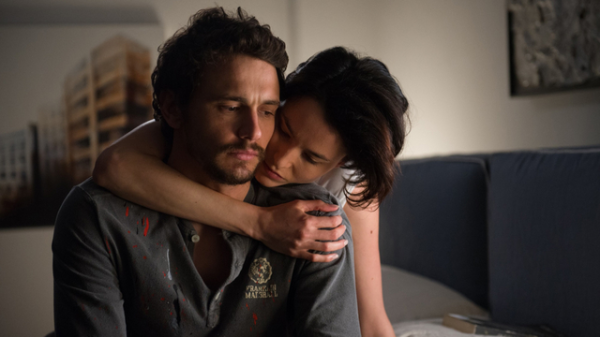What details in the background add depth to the image? In the background of the image, a painting depicting a modern, slightly abstract building adorns the wall. The sharp lines and the structure contrast subtly with the softer, more intimate interaction in the foreground. This juxtaposition adds a layer of artistic depth, suggesting themes of human connection versus the often cold, rigid structures of the modern world. Additionally, the simplicity of the room, with minimal distractions, emphasizes the focus on the emotional exchange between the two individuals, highlighting their bond. Imagine a fantastical scenario inspired by this image. In a world where emotions could manifest as physical entities, Daniel and Sarah find themselves in a room where their feelings become visible around them. As Sarah comforts Daniel, waves of color emanate from their bodies – Daniel’s somber blues and grays mixing with Sarah’s warm, comforting golds and pinks. The painting on the wall begins to shift and change, reflecting their inner worlds. The modern building in the painting morphs into a fantastical tower, with each window depicting a significant memory they've shared. As they embrace, the tower glows, emanating a soft light that fills the room, symbolizing hope and the everlasting power of their connection. This magical moment offers them a glimpse into their intertwined destinies, where love and friendship illuminate even the darkest corners of their lives. 